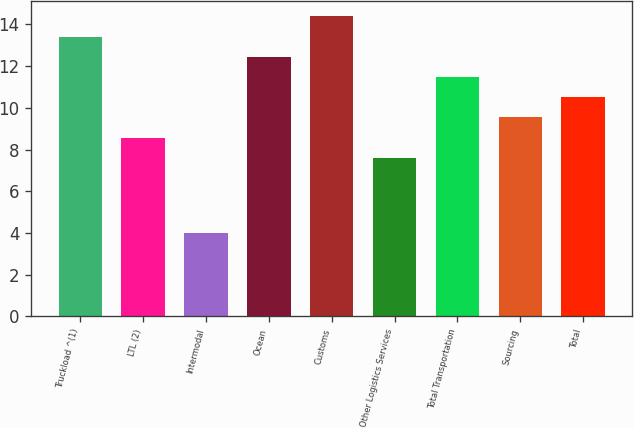<chart> <loc_0><loc_0><loc_500><loc_500><bar_chart><fcel>Truckload ^(1)<fcel>LTL (2)<fcel>Intermodal<fcel>Ocean<fcel>Customs<fcel>Other Logistics Services<fcel>Total Transportation<fcel>Sourcing<fcel>Total<nl><fcel>13.42<fcel>8.57<fcel>4<fcel>12.45<fcel>14.39<fcel>7.6<fcel>11.48<fcel>9.54<fcel>10.51<nl></chart> 